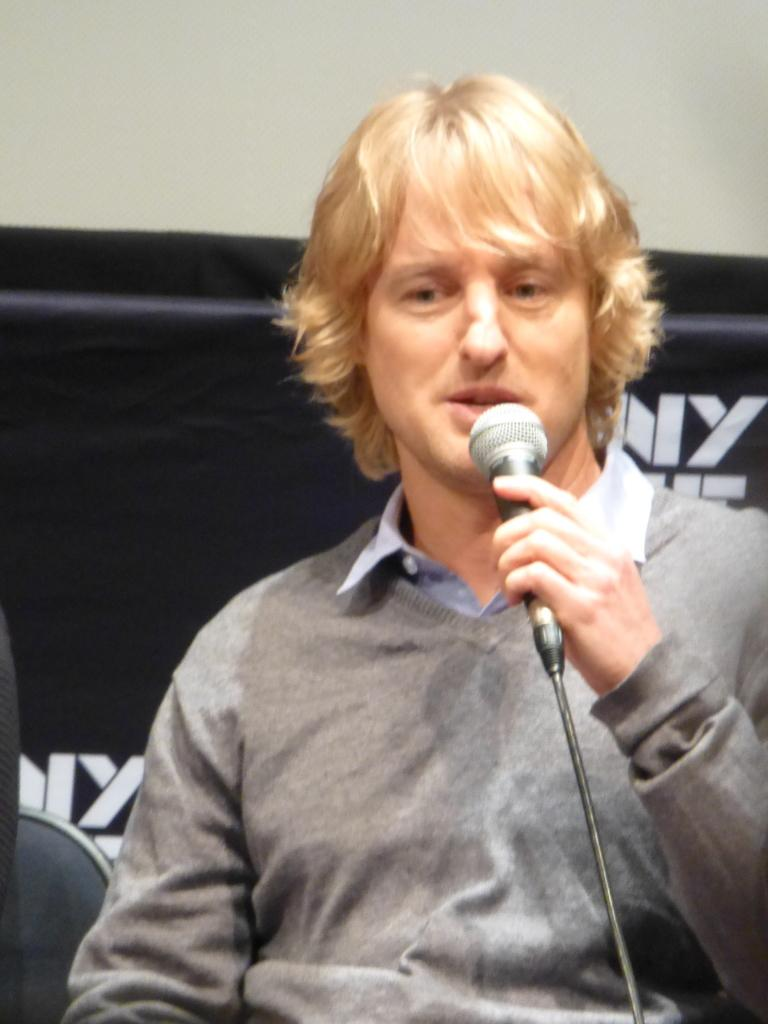What is the main subject of the image? The main subject of the image is a man. What is the man holding in the image? The man is holding a mic. Can you tell me how many yaks are present in the image? There are no yaks present in the image; it features a man holding a mic. What type of ground can be seen in the image? The provided facts do not mention the ground or any specific setting, so it cannot be determined from the image. 